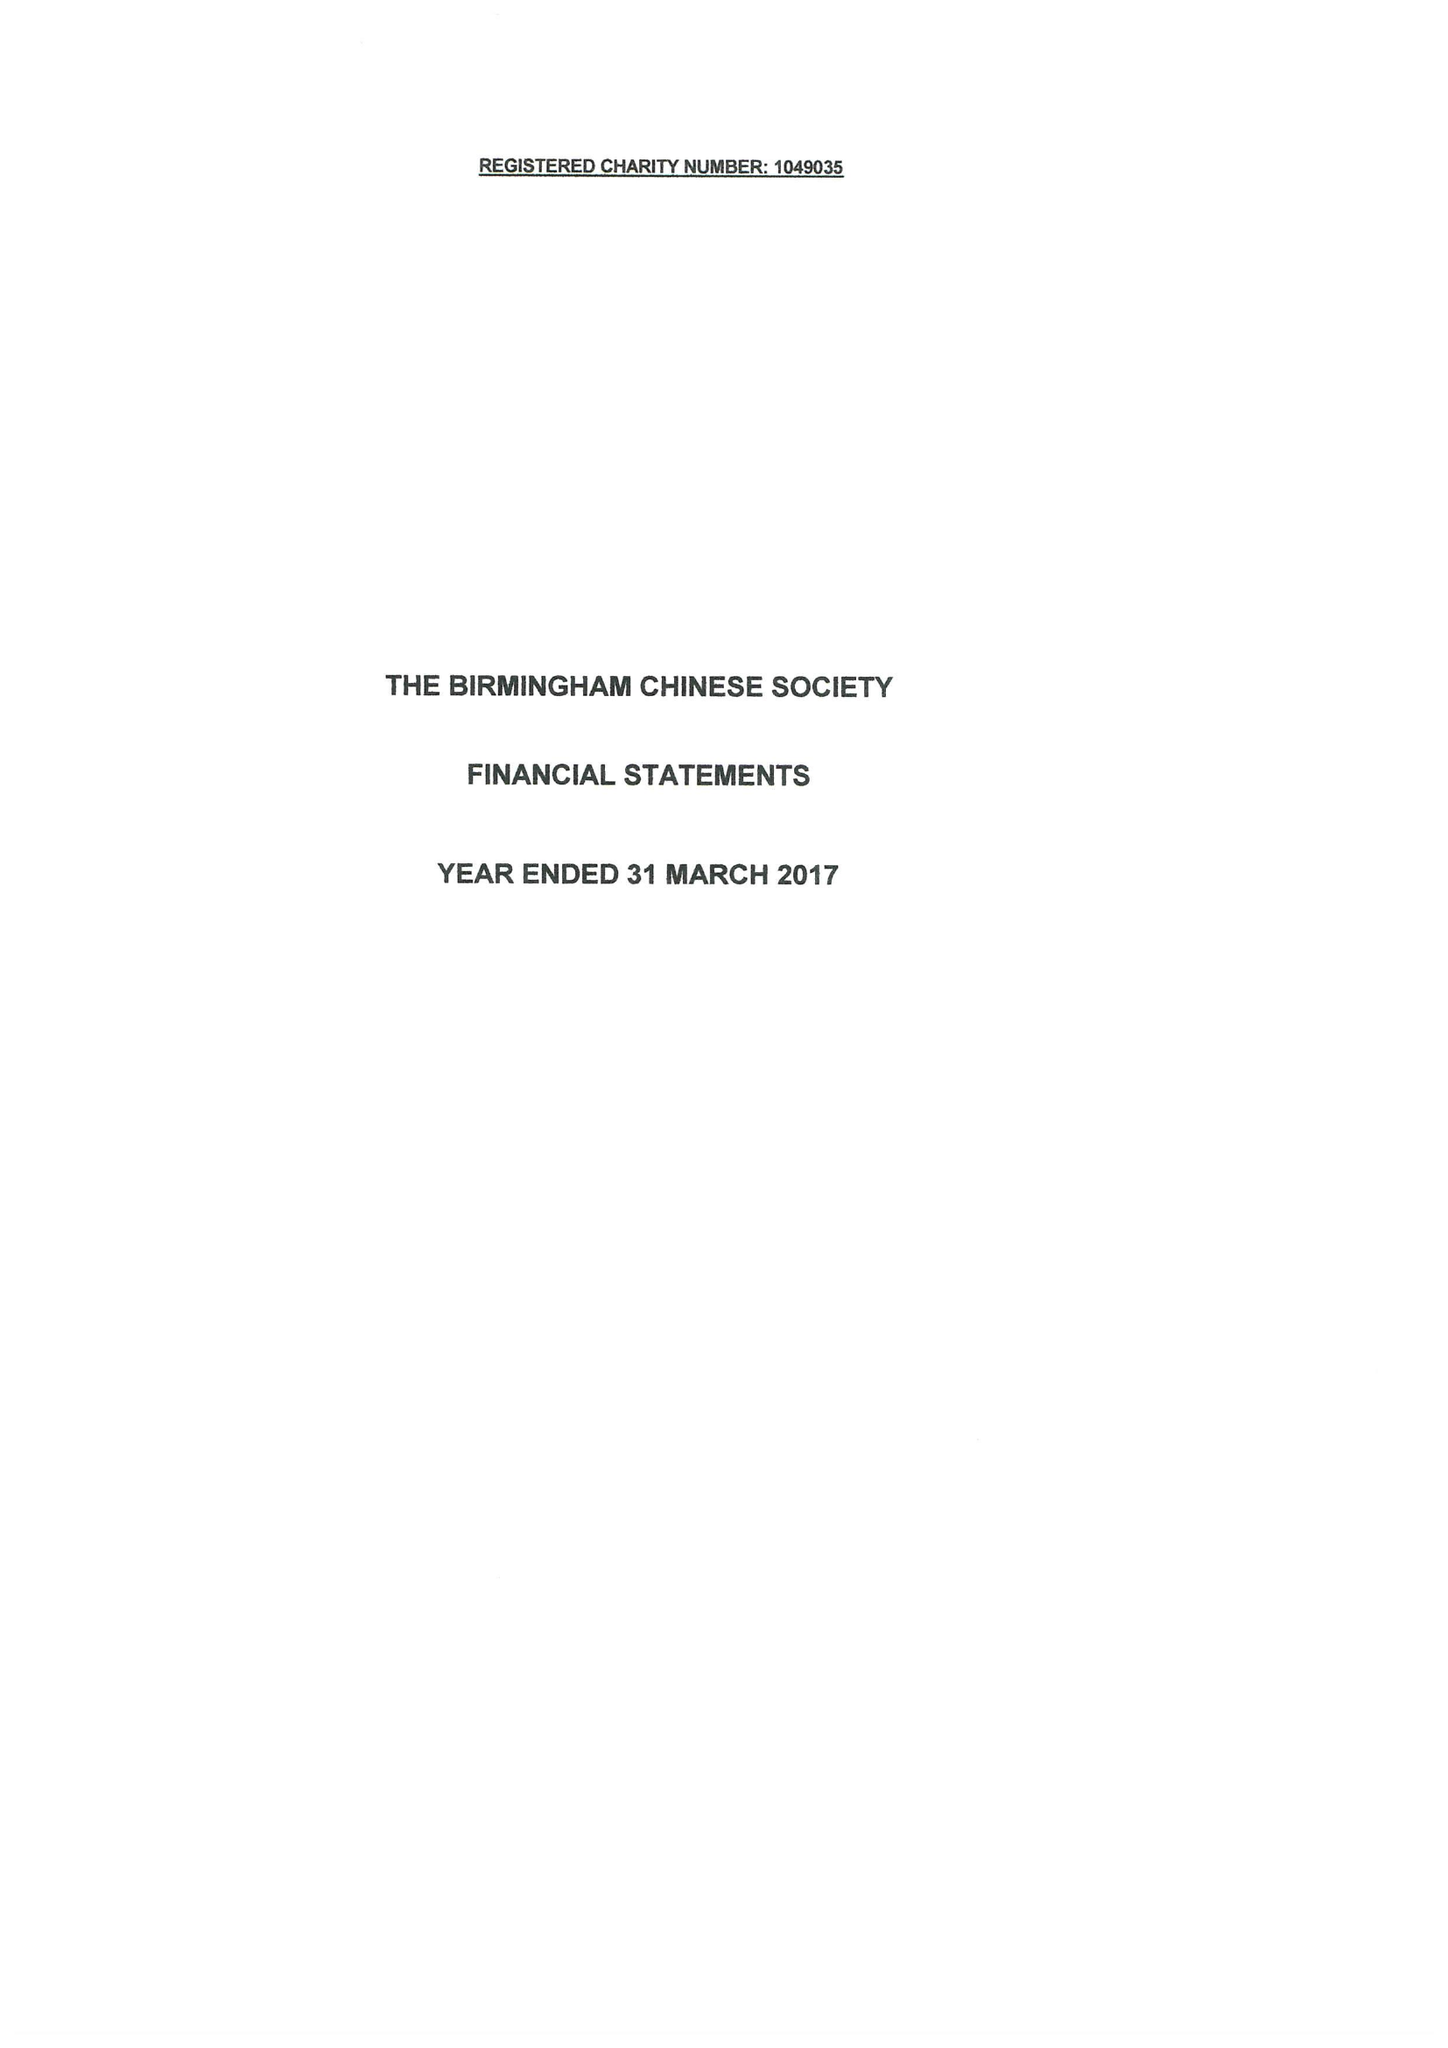What is the value for the report_date?
Answer the question using a single word or phrase. 2017-03-31 